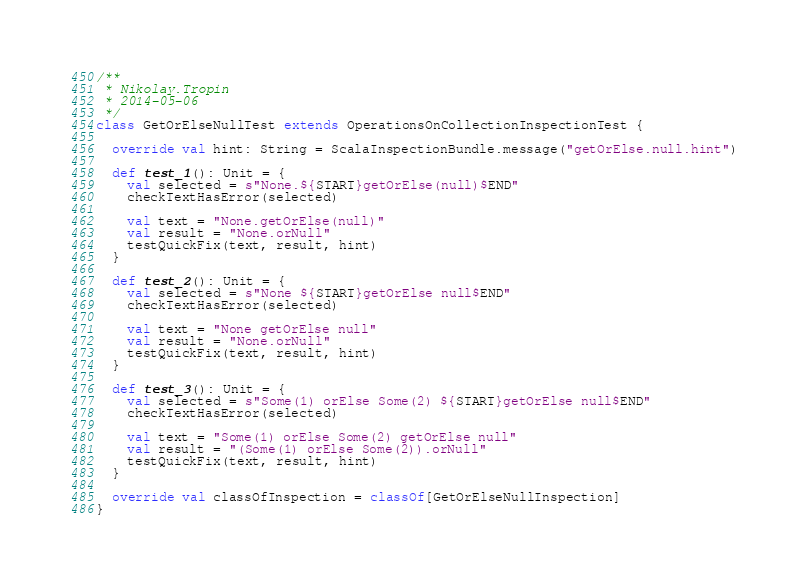Convert code to text. <code><loc_0><loc_0><loc_500><loc_500><_Scala_>
/**
 * Nikolay.Tropin
 * 2014-05-06
 */
class GetOrElseNullTest extends OperationsOnCollectionInspectionTest {

  override val hint: String = ScalaInspectionBundle.message("getOrElse.null.hint")

  def test_1(): Unit = {
    val selected = s"None.${START}getOrElse(null)$END"
    checkTextHasError(selected)

    val text = "None.getOrElse(null)"
    val result = "None.orNull"
    testQuickFix(text, result, hint)
  }

  def test_2(): Unit = {
    val selected = s"None ${START}getOrElse null$END"
    checkTextHasError(selected)

    val text = "None getOrElse null"
    val result = "None.orNull"
    testQuickFix(text, result, hint)
  }

  def test_3(): Unit = {
    val selected = s"Some(1) orElse Some(2) ${START}getOrElse null$END"
    checkTextHasError(selected)

    val text = "Some(1) orElse Some(2) getOrElse null"
    val result = "(Some(1) orElse Some(2)).orNull"
    testQuickFix(text, result, hint)
  }

  override val classOfInspection = classOf[GetOrElseNullInspection]
}
</code> 